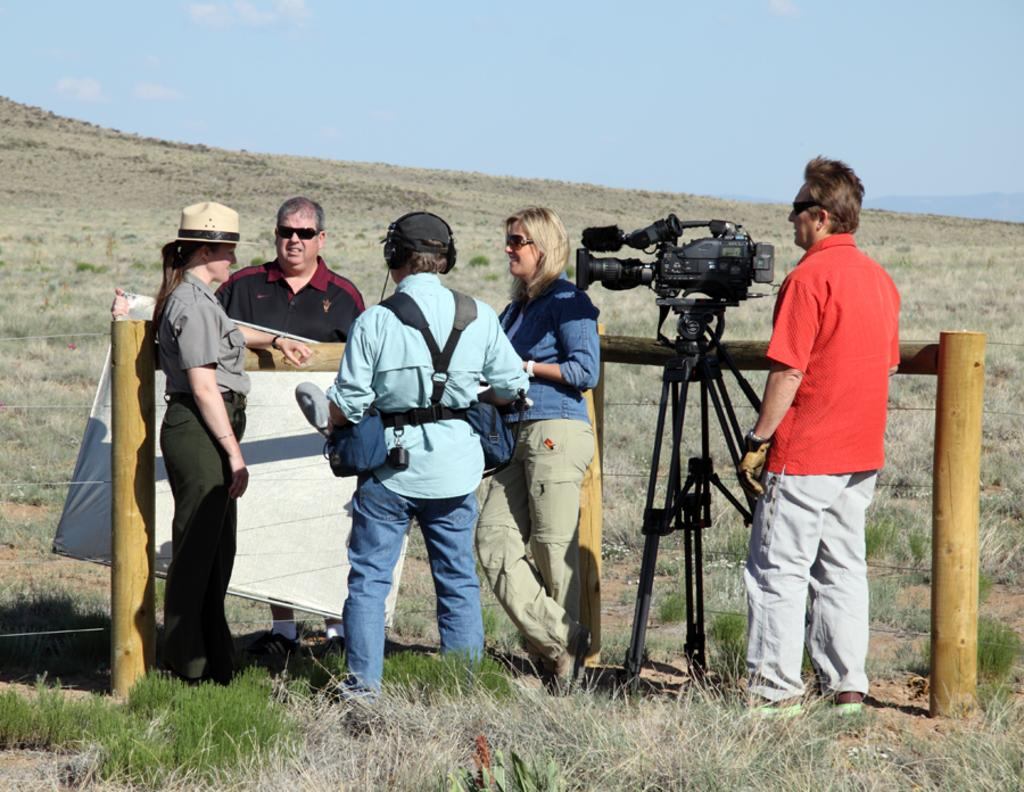What are the people in the image standing on? The people in the image are standing on the grass. What objects can be seen in the image besides the people? Wooden poles, a camera with a stand, and a person holding a board are visible in the image. What is the landscape feature in the background of the image? There is a hill in the background of the image. What is visible in the sky in the image? The sky is visible in the background of the image. What type of worm can be seen crawling on the grass in the image? There are no worms present in the image; it only features people, wooden poles, a camera with a stand, a person holding a board, a hill in the background, and the sky. 